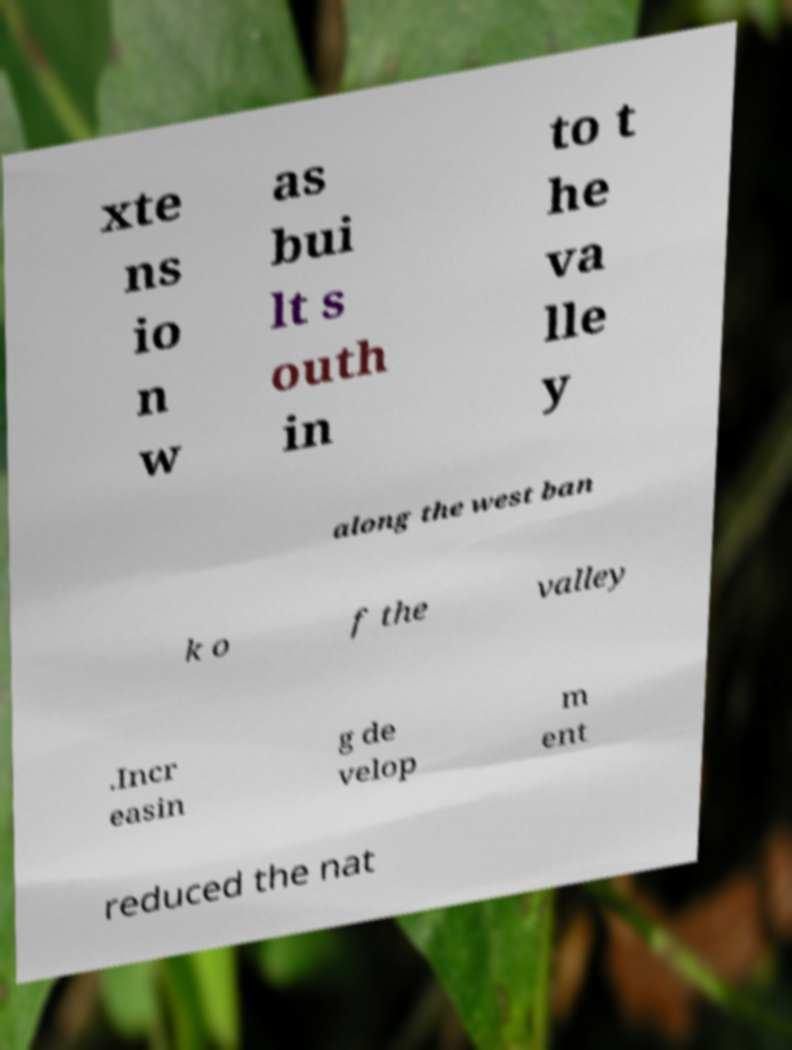Can you accurately transcribe the text from the provided image for me? xte ns io n w as bui lt s outh in to t he va lle y along the west ban k o f the valley .Incr easin g de velop m ent reduced the nat 